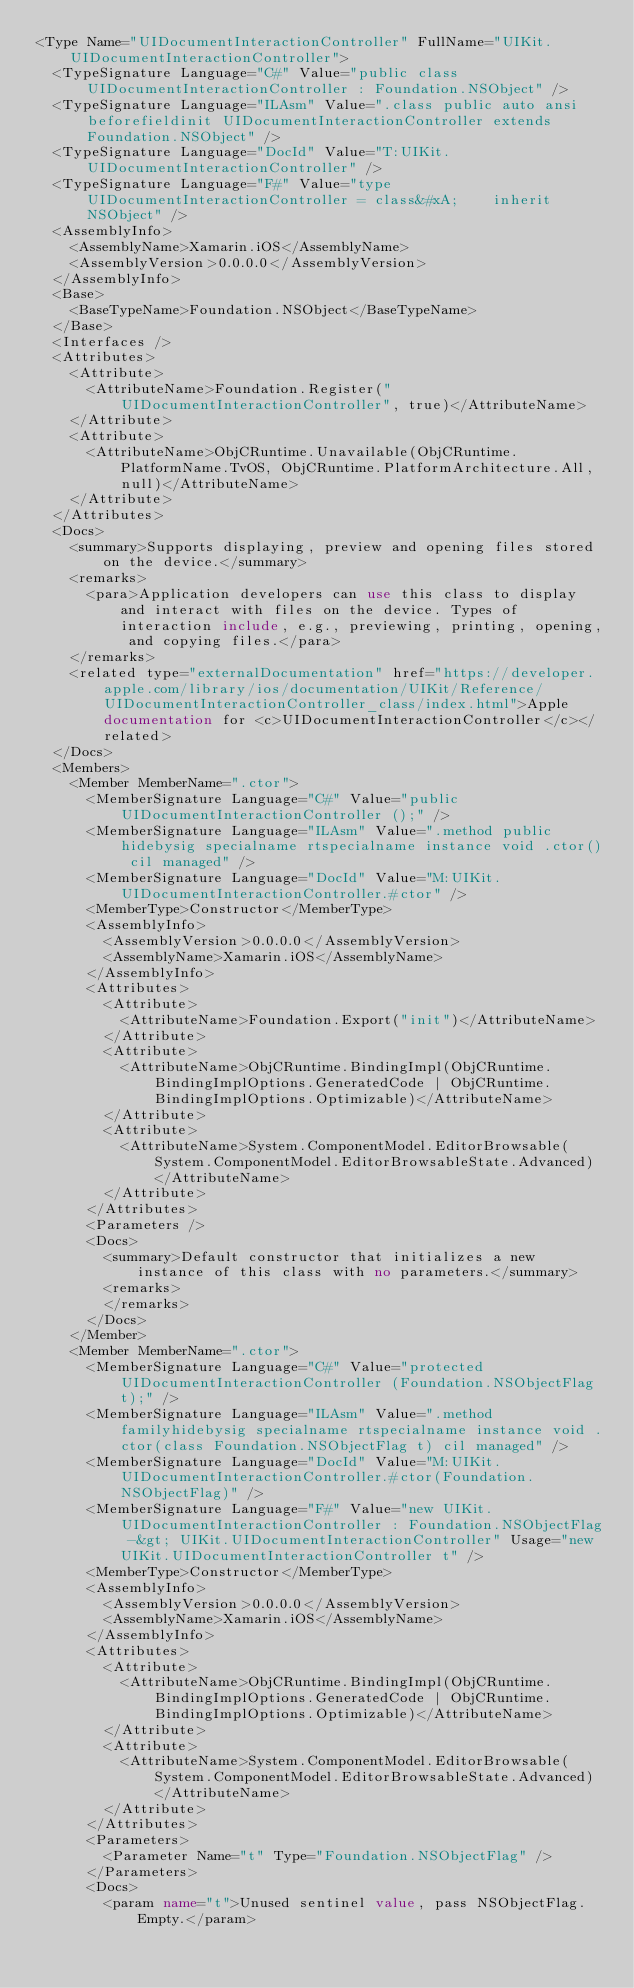<code> <loc_0><loc_0><loc_500><loc_500><_XML_><Type Name="UIDocumentInteractionController" FullName="UIKit.UIDocumentInteractionController">
  <TypeSignature Language="C#" Value="public class UIDocumentInteractionController : Foundation.NSObject" />
  <TypeSignature Language="ILAsm" Value=".class public auto ansi beforefieldinit UIDocumentInteractionController extends Foundation.NSObject" />
  <TypeSignature Language="DocId" Value="T:UIKit.UIDocumentInteractionController" />
  <TypeSignature Language="F#" Value="type UIDocumentInteractionController = class&#xA;    inherit NSObject" />
  <AssemblyInfo>
    <AssemblyName>Xamarin.iOS</AssemblyName>
    <AssemblyVersion>0.0.0.0</AssemblyVersion>
  </AssemblyInfo>
  <Base>
    <BaseTypeName>Foundation.NSObject</BaseTypeName>
  </Base>
  <Interfaces />
  <Attributes>
    <Attribute>
      <AttributeName>Foundation.Register("UIDocumentInteractionController", true)</AttributeName>
    </Attribute>
    <Attribute>
      <AttributeName>ObjCRuntime.Unavailable(ObjCRuntime.PlatformName.TvOS, ObjCRuntime.PlatformArchitecture.All, null)</AttributeName>
    </Attribute>
  </Attributes>
  <Docs>
    <summary>Supports displaying, preview and opening files stored on the device.</summary>
    <remarks>
      <para>Application developers can use this class to display and interact with files on the device. Types of interaction include, e.g., previewing, printing, opening, and copying files.</para>
    </remarks>
    <related type="externalDocumentation" href="https://developer.apple.com/library/ios/documentation/UIKit/Reference/UIDocumentInteractionController_class/index.html">Apple documentation for <c>UIDocumentInteractionController</c></related>
  </Docs>
  <Members>
    <Member MemberName=".ctor">
      <MemberSignature Language="C#" Value="public UIDocumentInteractionController ();" />
      <MemberSignature Language="ILAsm" Value=".method public hidebysig specialname rtspecialname instance void .ctor() cil managed" />
      <MemberSignature Language="DocId" Value="M:UIKit.UIDocumentInteractionController.#ctor" />
      <MemberType>Constructor</MemberType>
      <AssemblyInfo>
        <AssemblyVersion>0.0.0.0</AssemblyVersion>
        <AssemblyName>Xamarin.iOS</AssemblyName>
      </AssemblyInfo>
      <Attributes>
        <Attribute>
          <AttributeName>Foundation.Export("init")</AttributeName>
        </Attribute>
        <Attribute>
          <AttributeName>ObjCRuntime.BindingImpl(ObjCRuntime.BindingImplOptions.GeneratedCode | ObjCRuntime.BindingImplOptions.Optimizable)</AttributeName>
        </Attribute>
        <Attribute>
          <AttributeName>System.ComponentModel.EditorBrowsable(System.ComponentModel.EditorBrowsableState.Advanced)</AttributeName>
        </Attribute>
      </Attributes>
      <Parameters />
      <Docs>
        <summary>Default constructor that initializes a new instance of this class with no parameters.</summary>
        <remarks>
        </remarks>
      </Docs>
    </Member>
    <Member MemberName=".ctor">
      <MemberSignature Language="C#" Value="protected UIDocumentInteractionController (Foundation.NSObjectFlag t);" />
      <MemberSignature Language="ILAsm" Value=".method familyhidebysig specialname rtspecialname instance void .ctor(class Foundation.NSObjectFlag t) cil managed" />
      <MemberSignature Language="DocId" Value="M:UIKit.UIDocumentInteractionController.#ctor(Foundation.NSObjectFlag)" />
      <MemberSignature Language="F#" Value="new UIKit.UIDocumentInteractionController : Foundation.NSObjectFlag -&gt; UIKit.UIDocumentInteractionController" Usage="new UIKit.UIDocumentInteractionController t" />
      <MemberType>Constructor</MemberType>
      <AssemblyInfo>
        <AssemblyVersion>0.0.0.0</AssemblyVersion>
        <AssemblyName>Xamarin.iOS</AssemblyName>
      </AssemblyInfo>
      <Attributes>
        <Attribute>
          <AttributeName>ObjCRuntime.BindingImpl(ObjCRuntime.BindingImplOptions.GeneratedCode | ObjCRuntime.BindingImplOptions.Optimizable)</AttributeName>
        </Attribute>
        <Attribute>
          <AttributeName>System.ComponentModel.EditorBrowsable(System.ComponentModel.EditorBrowsableState.Advanced)</AttributeName>
        </Attribute>
      </Attributes>
      <Parameters>
        <Parameter Name="t" Type="Foundation.NSObjectFlag" />
      </Parameters>
      <Docs>
        <param name="t">Unused sentinel value, pass NSObjectFlag.Empty.</param></code> 